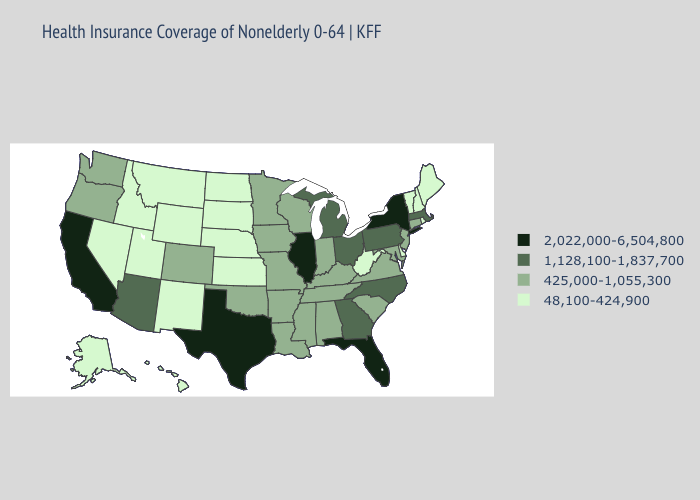Name the states that have a value in the range 2,022,000-6,504,800?
Concise answer only. California, Florida, Illinois, New York, Texas. Does Indiana have a lower value than Virginia?
Short answer required. No. Does Washington have the lowest value in the USA?
Keep it brief. No. Which states have the highest value in the USA?
Concise answer only. California, Florida, Illinois, New York, Texas. Name the states that have a value in the range 2,022,000-6,504,800?
Short answer required. California, Florida, Illinois, New York, Texas. What is the value of Wyoming?
Write a very short answer. 48,100-424,900. What is the highest value in states that border Ohio?
Keep it brief. 1,128,100-1,837,700. What is the value of Montana?
Quick response, please. 48,100-424,900. What is the value of Maryland?
Answer briefly. 425,000-1,055,300. What is the value of Louisiana?
Be succinct. 425,000-1,055,300. Does Texas have the lowest value in the South?
Write a very short answer. No. Name the states that have a value in the range 425,000-1,055,300?
Keep it brief. Alabama, Arkansas, Colorado, Connecticut, Indiana, Iowa, Kentucky, Louisiana, Maryland, Minnesota, Mississippi, Missouri, New Jersey, Oklahoma, Oregon, South Carolina, Tennessee, Virginia, Washington, Wisconsin. What is the value of Montana?
Write a very short answer. 48,100-424,900. Is the legend a continuous bar?
Write a very short answer. No. Name the states that have a value in the range 48,100-424,900?
Short answer required. Alaska, Delaware, Hawaii, Idaho, Kansas, Maine, Montana, Nebraska, Nevada, New Hampshire, New Mexico, North Dakota, Rhode Island, South Dakota, Utah, Vermont, West Virginia, Wyoming. 